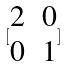<formula> <loc_0><loc_0><loc_500><loc_500>[ \begin{matrix} 2 & 0 \\ 0 & 1 \end{matrix} ]</formula> 